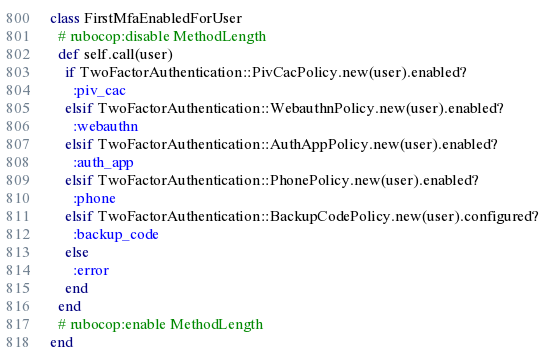Convert code to text. <code><loc_0><loc_0><loc_500><loc_500><_Ruby_>class FirstMfaEnabledForUser
  # rubocop:disable MethodLength
  def self.call(user)
    if TwoFactorAuthentication::PivCacPolicy.new(user).enabled?
      :piv_cac
    elsif TwoFactorAuthentication::WebauthnPolicy.new(user).enabled?
      :webauthn
    elsif TwoFactorAuthentication::AuthAppPolicy.new(user).enabled?
      :auth_app
    elsif TwoFactorAuthentication::PhonePolicy.new(user).enabled?
      :phone
    elsif TwoFactorAuthentication::BackupCodePolicy.new(user).configured?
      :backup_code
    else
      :error
    end
  end
  # rubocop:enable MethodLength
end
</code> 